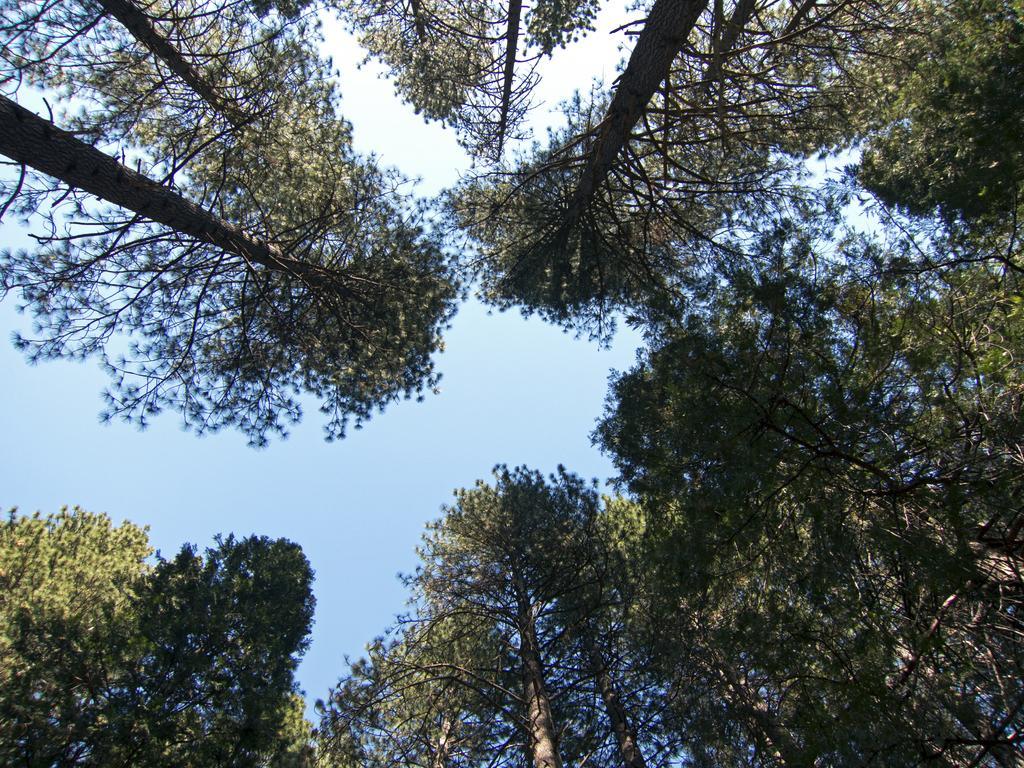How would you summarize this image in a sentence or two? This image is taken from the bottom to the top. There are so many tall trees in the circular manner. At the top there is the sky. 